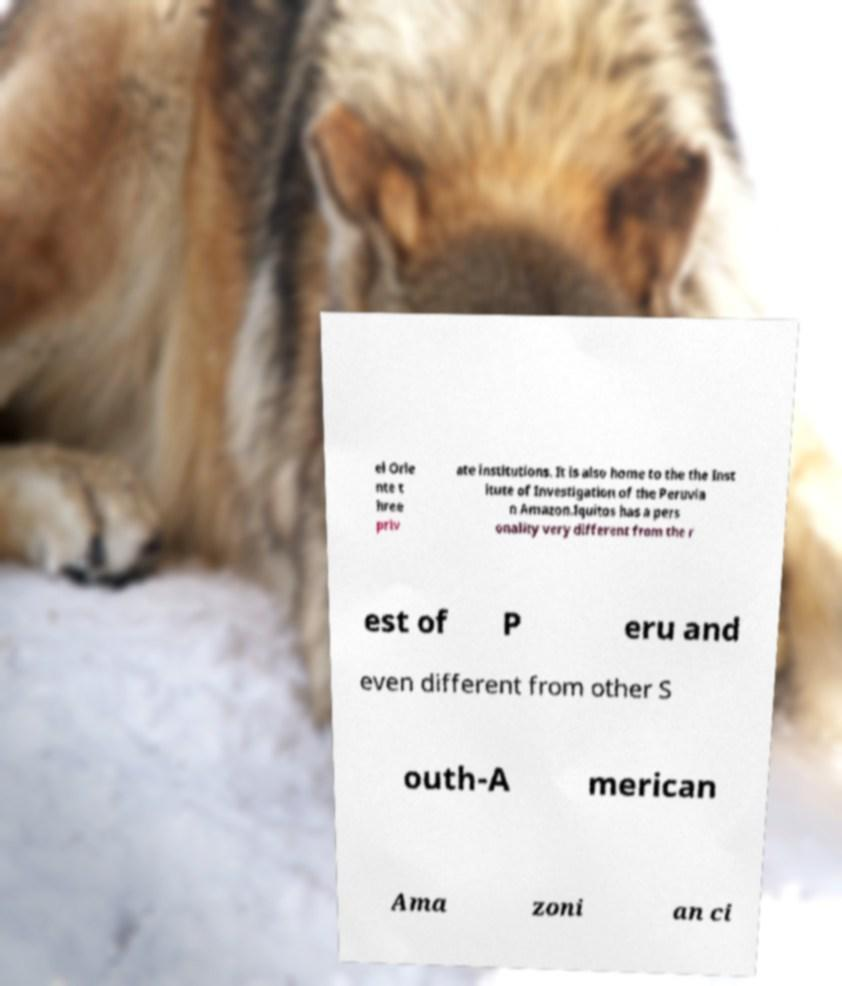What messages or text are displayed in this image? I need them in a readable, typed format. el Orie nte t hree priv ate institutions. It is also home to the the Inst itute of Investigation of the Peruvia n Amazon.Iquitos has a pers onality very different from the r est of P eru and even different from other S outh-A merican Ama zoni an ci 